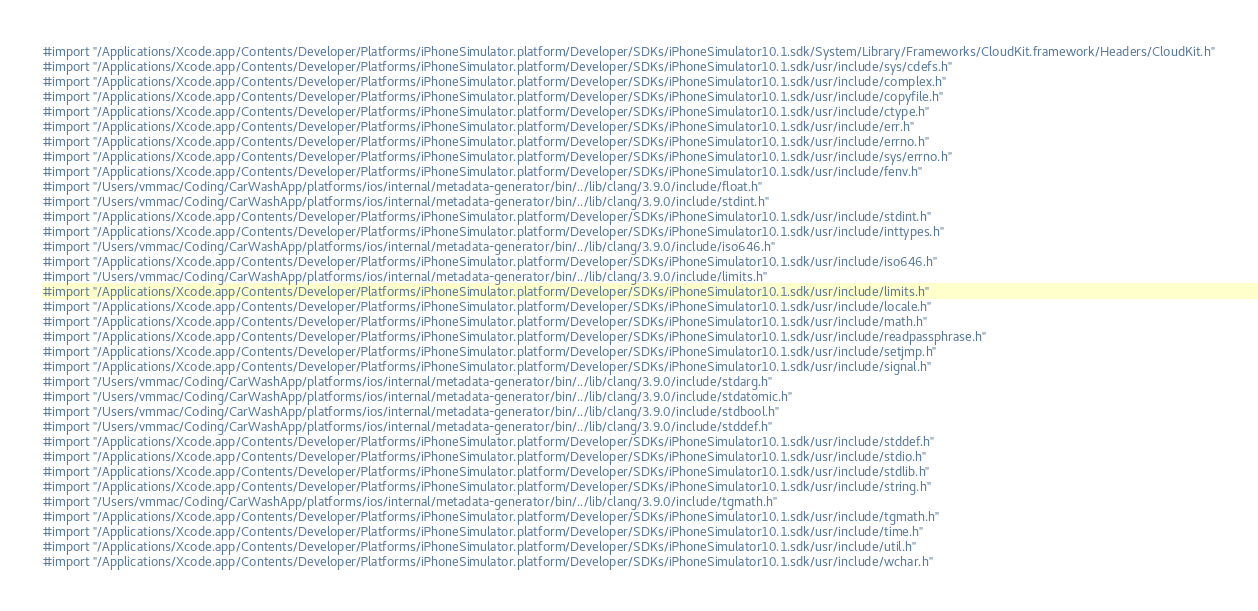Convert code to text. <code><loc_0><loc_0><loc_500><loc_500><_C_>#import "/Applications/Xcode.app/Contents/Developer/Platforms/iPhoneSimulator.platform/Developer/SDKs/iPhoneSimulator10.1.sdk/System/Library/Frameworks/CloudKit.framework/Headers/CloudKit.h"
#import "/Applications/Xcode.app/Contents/Developer/Platforms/iPhoneSimulator.platform/Developer/SDKs/iPhoneSimulator10.1.sdk/usr/include/sys/cdefs.h"
#import "/Applications/Xcode.app/Contents/Developer/Platforms/iPhoneSimulator.platform/Developer/SDKs/iPhoneSimulator10.1.sdk/usr/include/complex.h"
#import "/Applications/Xcode.app/Contents/Developer/Platforms/iPhoneSimulator.platform/Developer/SDKs/iPhoneSimulator10.1.sdk/usr/include/copyfile.h"
#import "/Applications/Xcode.app/Contents/Developer/Platforms/iPhoneSimulator.platform/Developer/SDKs/iPhoneSimulator10.1.sdk/usr/include/ctype.h"
#import "/Applications/Xcode.app/Contents/Developer/Platforms/iPhoneSimulator.platform/Developer/SDKs/iPhoneSimulator10.1.sdk/usr/include/err.h"
#import "/Applications/Xcode.app/Contents/Developer/Platforms/iPhoneSimulator.platform/Developer/SDKs/iPhoneSimulator10.1.sdk/usr/include/errno.h"
#import "/Applications/Xcode.app/Contents/Developer/Platforms/iPhoneSimulator.platform/Developer/SDKs/iPhoneSimulator10.1.sdk/usr/include/sys/errno.h"
#import "/Applications/Xcode.app/Contents/Developer/Platforms/iPhoneSimulator.platform/Developer/SDKs/iPhoneSimulator10.1.sdk/usr/include/fenv.h"
#import "/Users/vmmac/Coding/CarWashApp/platforms/ios/internal/metadata-generator/bin/../lib/clang/3.9.0/include/float.h"
#import "/Users/vmmac/Coding/CarWashApp/platforms/ios/internal/metadata-generator/bin/../lib/clang/3.9.0/include/stdint.h"
#import "/Applications/Xcode.app/Contents/Developer/Platforms/iPhoneSimulator.platform/Developer/SDKs/iPhoneSimulator10.1.sdk/usr/include/stdint.h"
#import "/Applications/Xcode.app/Contents/Developer/Platforms/iPhoneSimulator.platform/Developer/SDKs/iPhoneSimulator10.1.sdk/usr/include/inttypes.h"
#import "/Users/vmmac/Coding/CarWashApp/platforms/ios/internal/metadata-generator/bin/../lib/clang/3.9.0/include/iso646.h"
#import "/Applications/Xcode.app/Contents/Developer/Platforms/iPhoneSimulator.platform/Developer/SDKs/iPhoneSimulator10.1.sdk/usr/include/iso646.h"
#import "/Users/vmmac/Coding/CarWashApp/platforms/ios/internal/metadata-generator/bin/../lib/clang/3.9.0/include/limits.h"
#import "/Applications/Xcode.app/Contents/Developer/Platforms/iPhoneSimulator.platform/Developer/SDKs/iPhoneSimulator10.1.sdk/usr/include/limits.h"
#import "/Applications/Xcode.app/Contents/Developer/Platforms/iPhoneSimulator.platform/Developer/SDKs/iPhoneSimulator10.1.sdk/usr/include/locale.h"
#import "/Applications/Xcode.app/Contents/Developer/Platforms/iPhoneSimulator.platform/Developer/SDKs/iPhoneSimulator10.1.sdk/usr/include/math.h"
#import "/Applications/Xcode.app/Contents/Developer/Platforms/iPhoneSimulator.platform/Developer/SDKs/iPhoneSimulator10.1.sdk/usr/include/readpassphrase.h"
#import "/Applications/Xcode.app/Contents/Developer/Platforms/iPhoneSimulator.platform/Developer/SDKs/iPhoneSimulator10.1.sdk/usr/include/setjmp.h"
#import "/Applications/Xcode.app/Contents/Developer/Platforms/iPhoneSimulator.platform/Developer/SDKs/iPhoneSimulator10.1.sdk/usr/include/signal.h"
#import "/Users/vmmac/Coding/CarWashApp/platforms/ios/internal/metadata-generator/bin/../lib/clang/3.9.0/include/stdarg.h"
#import "/Users/vmmac/Coding/CarWashApp/platforms/ios/internal/metadata-generator/bin/../lib/clang/3.9.0/include/stdatomic.h"
#import "/Users/vmmac/Coding/CarWashApp/platforms/ios/internal/metadata-generator/bin/../lib/clang/3.9.0/include/stdbool.h"
#import "/Users/vmmac/Coding/CarWashApp/platforms/ios/internal/metadata-generator/bin/../lib/clang/3.9.0/include/stddef.h"
#import "/Applications/Xcode.app/Contents/Developer/Platforms/iPhoneSimulator.platform/Developer/SDKs/iPhoneSimulator10.1.sdk/usr/include/stddef.h"
#import "/Applications/Xcode.app/Contents/Developer/Platforms/iPhoneSimulator.platform/Developer/SDKs/iPhoneSimulator10.1.sdk/usr/include/stdio.h"
#import "/Applications/Xcode.app/Contents/Developer/Platforms/iPhoneSimulator.platform/Developer/SDKs/iPhoneSimulator10.1.sdk/usr/include/stdlib.h"
#import "/Applications/Xcode.app/Contents/Developer/Platforms/iPhoneSimulator.platform/Developer/SDKs/iPhoneSimulator10.1.sdk/usr/include/string.h"
#import "/Users/vmmac/Coding/CarWashApp/platforms/ios/internal/metadata-generator/bin/../lib/clang/3.9.0/include/tgmath.h"
#import "/Applications/Xcode.app/Contents/Developer/Platforms/iPhoneSimulator.platform/Developer/SDKs/iPhoneSimulator10.1.sdk/usr/include/tgmath.h"
#import "/Applications/Xcode.app/Contents/Developer/Platforms/iPhoneSimulator.platform/Developer/SDKs/iPhoneSimulator10.1.sdk/usr/include/time.h"
#import "/Applications/Xcode.app/Contents/Developer/Platforms/iPhoneSimulator.platform/Developer/SDKs/iPhoneSimulator10.1.sdk/usr/include/util.h"
#import "/Applications/Xcode.app/Contents/Developer/Platforms/iPhoneSimulator.platform/Developer/SDKs/iPhoneSimulator10.1.sdk/usr/include/wchar.h"</code> 